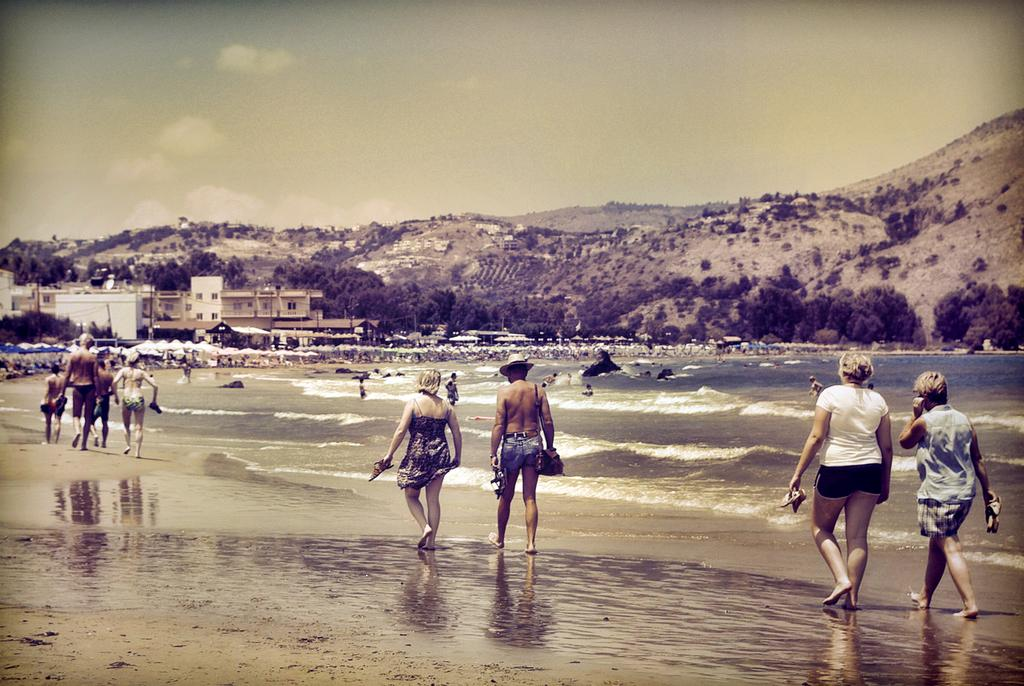What are the people in the image doing? The people in the image are walking on the beach. What can be seen in the background of the image? Umbrellas, chairs, water, buildings, hills, and the sky are visible in the background of the image. What is the condition of the sky in the image? Clouds are present in the sky. What type of eye can be seen in the image? There is no eye present in the image. What is the hammer being used for in the image? There is no hammer present in the image. 